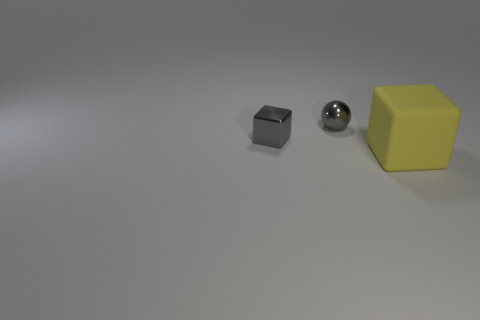Is the color of the ball the same as the cube that is on the left side of the yellow matte block?
Give a very brief answer. Yes. What material is the gray thing that is in front of the gray shiny ball?
Keep it short and to the point. Metal. Are there any tiny shiny balls that have the same color as the small cube?
Offer a terse response. Yes. There is a metallic cube that is the same size as the metal sphere; what color is it?
Provide a succinct answer. Gray. How many tiny things are either green metal cylinders or balls?
Offer a very short reply. 1. Are there an equal number of big yellow matte things that are behind the big rubber block and small things that are in front of the tiny metal block?
Your answer should be compact. Yes. How many gray metallic cubes are the same size as the gray metallic sphere?
Offer a very short reply. 1. What number of purple things are either matte blocks or cubes?
Your answer should be compact. 0. Are there the same number of gray cubes that are right of the yellow object and green metal spheres?
Your response must be concise. Yes. There is a block that is to the right of the tiny metal block; what size is it?
Keep it short and to the point. Large. 